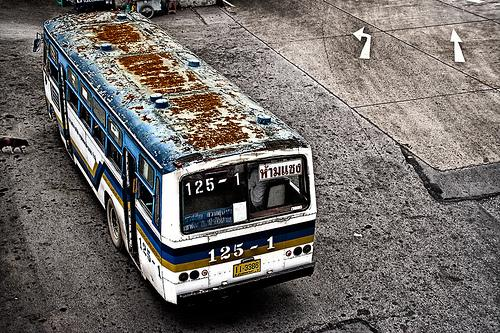What work does this bus need to have done on it? Please explain your reasoning. paint roof. The bus needs the roof cleared and painted. 